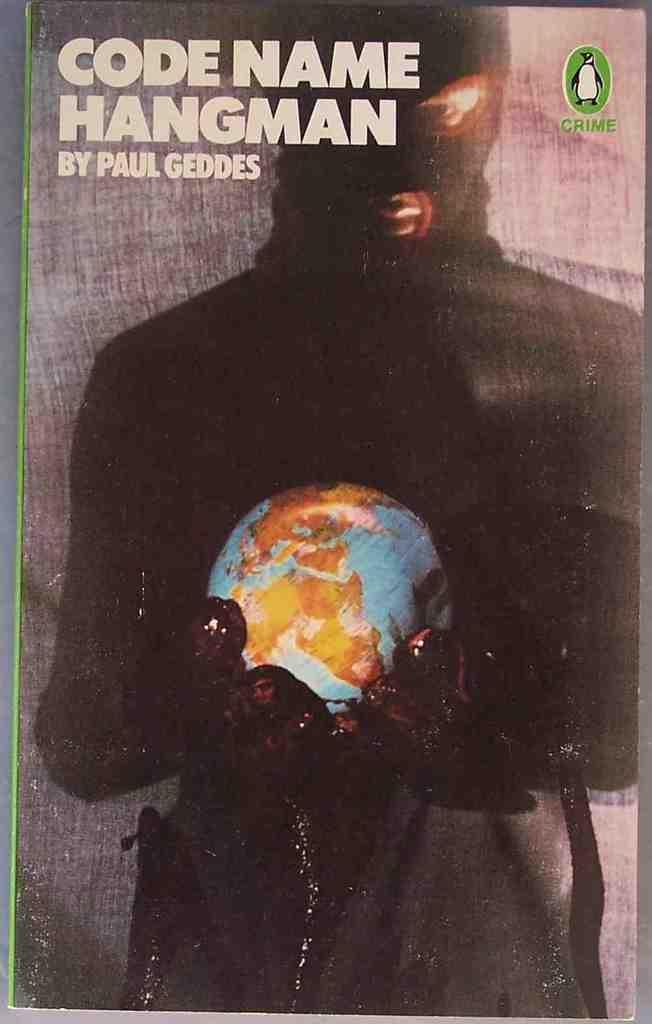Who wrote this book?
Give a very brief answer. Paul geddes. What is the name of this book?
Your response must be concise. Code name hangman. 